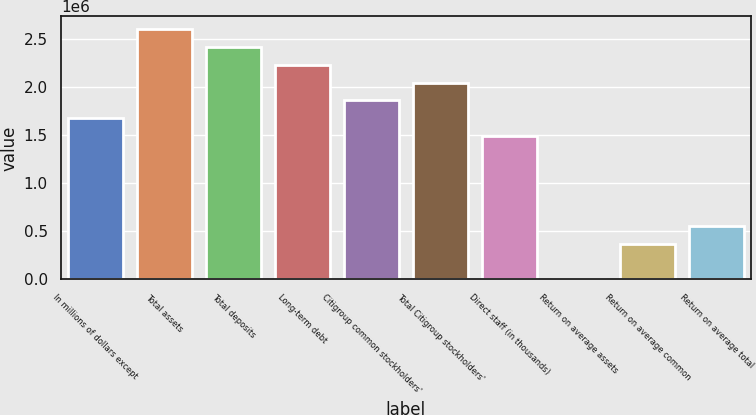Convert chart to OTSL. <chart><loc_0><loc_0><loc_500><loc_500><bar_chart><fcel>In millions of dollars except<fcel>Total assets<fcel>Total deposits<fcel>Long-term debt<fcel>Citigroup common stockholders'<fcel>Total Citigroup stockholders'<fcel>Direct staff (in thousands)<fcel>Return on average assets<fcel>Return on average common<fcel>Return on average total<nl><fcel>1.6779e+06<fcel>2.61006e+06<fcel>2.42363e+06<fcel>2.23719e+06<fcel>1.86433e+06<fcel>2.05076e+06<fcel>1.49146e+06<fcel>0.39<fcel>372866<fcel>559299<nl></chart> 